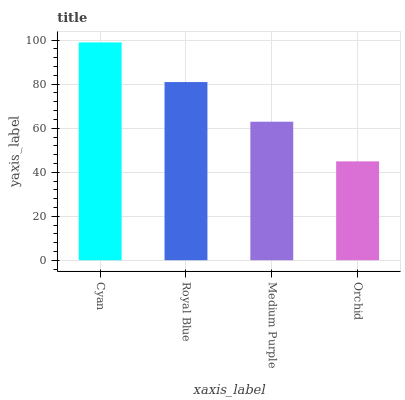Is Orchid the minimum?
Answer yes or no. Yes. Is Cyan the maximum?
Answer yes or no. Yes. Is Royal Blue the minimum?
Answer yes or no. No. Is Royal Blue the maximum?
Answer yes or no. No. Is Cyan greater than Royal Blue?
Answer yes or no. Yes. Is Royal Blue less than Cyan?
Answer yes or no. Yes. Is Royal Blue greater than Cyan?
Answer yes or no. No. Is Cyan less than Royal Blue?
Answer yes or no. No. Is Royal Blue the high median?
Answer yes or no. Yes. Is Medium Purple the low median?
Answer yes or no. Yes. Is Cyan the high median?
Answer yes or no. No. Is Orchid the low median?
Answer yes or no. No. 